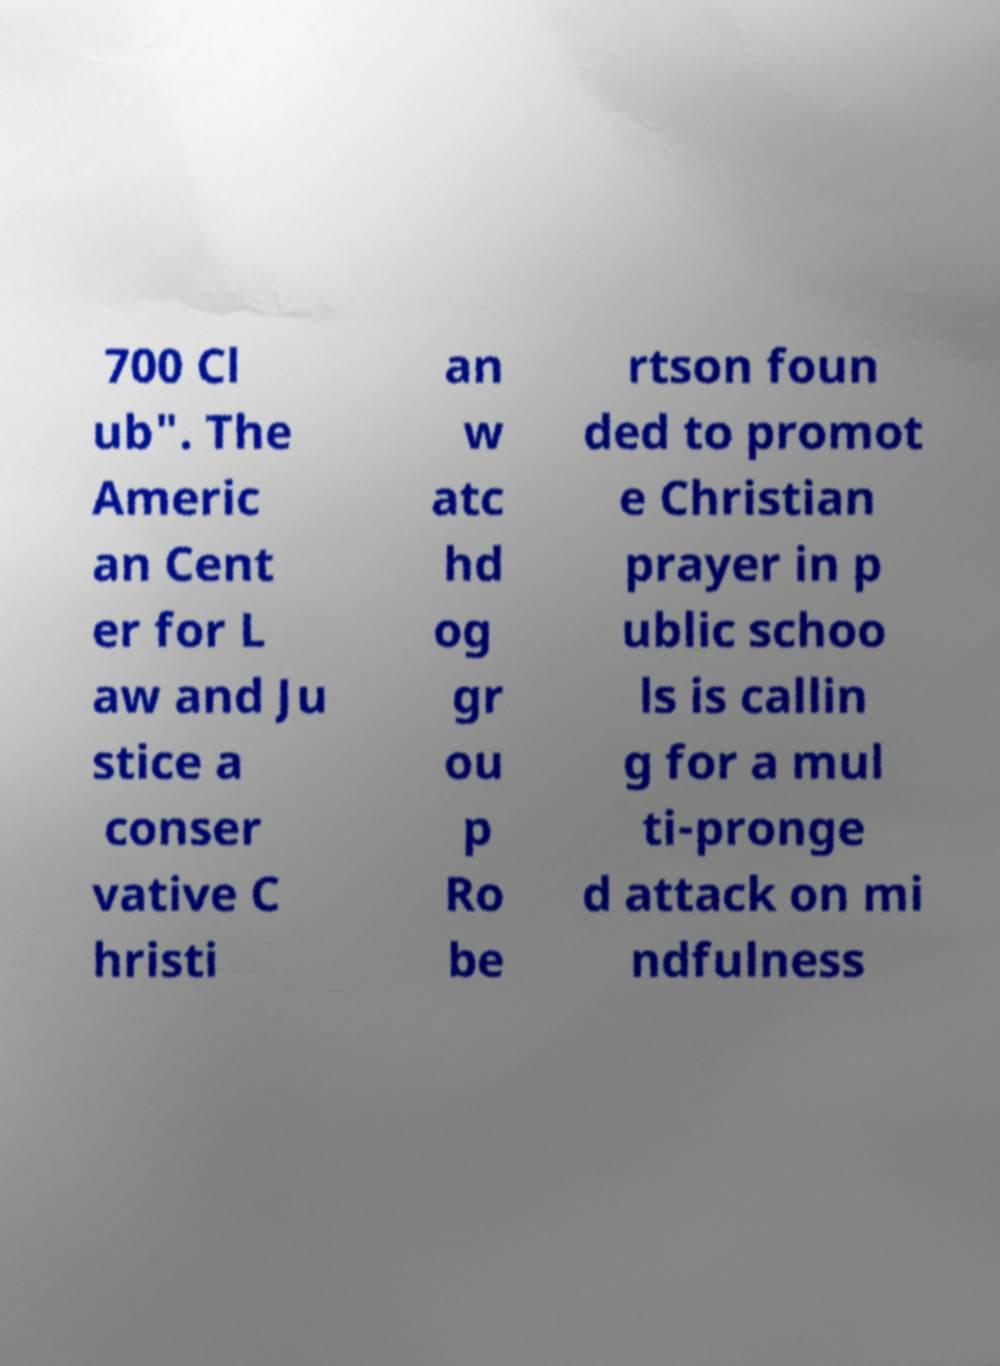I need the written content from this picture converted into text. Can you do that? 700 Cl ub". The Americ an Cent er for L aw and Ju stice a conser vative C hristi an w atc hd og gr ou p Ro be rtson foun ded to promot e Christian prayer in p ublic schoo ls is callin g for a mul ti-pronge d attack on mi ndfulness 